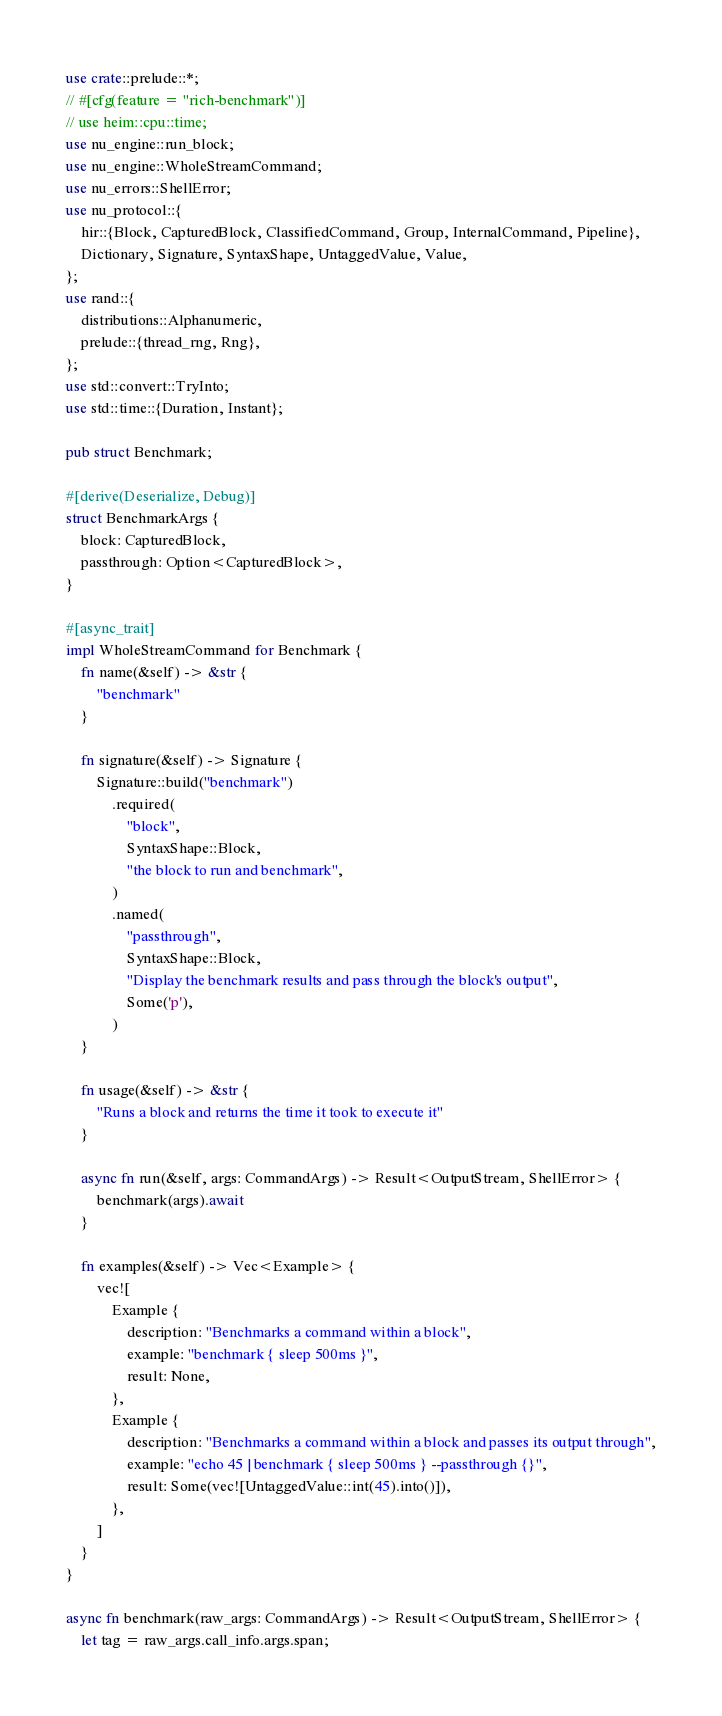<code> <loc_0><loc_0><loc_500><loc_500><_Rust_>use crate::prelude::*;
// #[cfg(feature = "rich-benchmark")]
// use heim::cpu::time;
use nu_engine::run_block;
use nu_engine::WholeStreamCommand;
use nu_errors::ShellError;
use nu_protocol::{
    hir::{Block, CapturedBlock, ClassifiedCommand, Group, InternalCommand, Pipeline},
    Dictionary, Signature, SyntaxShape, UntaggedValue, Value,
};
use rand::{
    distributions::Alphanumeric,
    prelude::{thread_rng, Rng},
};
use std::convert::TryInto;
use std::time::{Duration, Instant};

pub struct Benchmark;

#[derive(Deserialize, Debug)]
struct BenchmarkArgs {
    block: CapturedBlock,
    passthrough: Option<CapturedBlock>,
}

#[async_trait]
impl WholeStreamCommand for Benchmark {
    fn name(&self) -> &str {
        "benchmark"
    }

    fn signature(&self) -> Signature {
        Signature::build("benchmark")
            .required(
                "block",
                SyntaxShape::Block,
                "the block to run and benchmark",
            )
            .named(
                "passthrough",
                SyntaxShape::Block,
                "Display the benchmark results and pass through the block's output",
                Some('p'),
            )
    }

    fn usage(&self) -> &str {
        "Runs a block and returns the time it took to execute it"
    }

    async fn run(&self, args: CommandArgs) -> Result<OutputStream, ShellError> {
        benchmark(args).await
    }

    fn examples(&self) -> Vec<Example> {
        vec![
            Example {
                description: "Benchmarks a command within a block",
                example: "benchmark { sleep 500ms }",
                result: None,
            },
            Example {
                description: "Benchmarks a command within a block and passes its output through",
                example: "echo 45 | benchmark { sleep 500ms } --passthrough {}",
                result: Some(vec![UntaggedValue::int(45).into()]),
            },
        ]
    }
}

async fn benchmark(raw_args: CommandArgs) -> Result<OutputStream, ShellError> {
    let tag = raw_args.call_info.args.span;</code> 